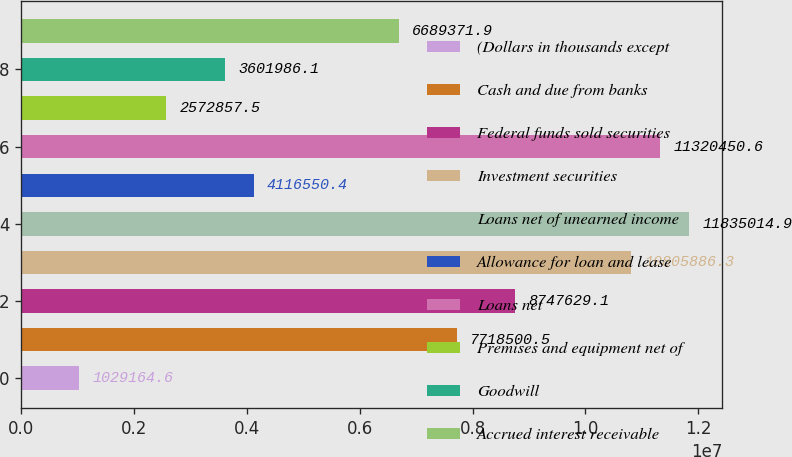<chart> <loc_0><loc_0><loc_500><loc_500><bar_chart><fcel>(Dollars in thousands except<fcel>Cash and due from banks<fcel>Federal funds sold securities<fcel>Investment securities<fcel>Loans net of unearned income<fcel>Allowance for loan and lease<fcel>Loans net<fcel>Premises and equipment net of<fcel>Goodwill<fcel>Accrued interest receivable<nl><fcel>1.02916e+06<fcel>7.7185e+06<fcel>8.74763e+06<fcel>1.08059e+07<fcel>1.1835e+07<fcel>4.11655e+06<fcel>1.13205e+07<fcel>2.57286e+06<fcel>3.60199e+06<fcel>6.68937e+06<nl></chart> 